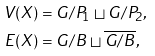<formula> <loc_0><loc_0><loc_500><loc_500>V ( X ) & = G / P _ { 1 } \sqcup G / P _ { 2 } , \\ E ( X ) & = G / B \sqcup \overline { G / B } ,</formula> 